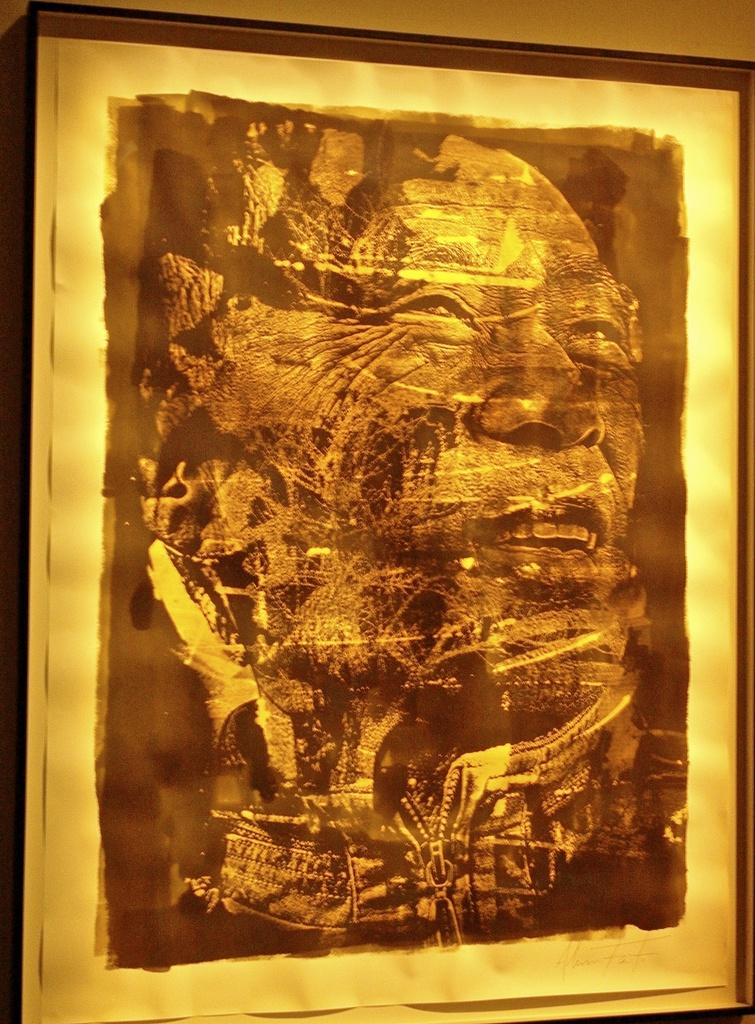What type of artwork is present in the image? There is a photograph and a painting in the image. Can you describe the photograph in the image? Unfortunately, the details of the photograph cannot be determined from the provided facts. Can you describe the painting in the image? Unfortunately, the details of the painting cannot be determined from the provided facts. What book is the cub reading in the image? There is no cub or book present in the image. 